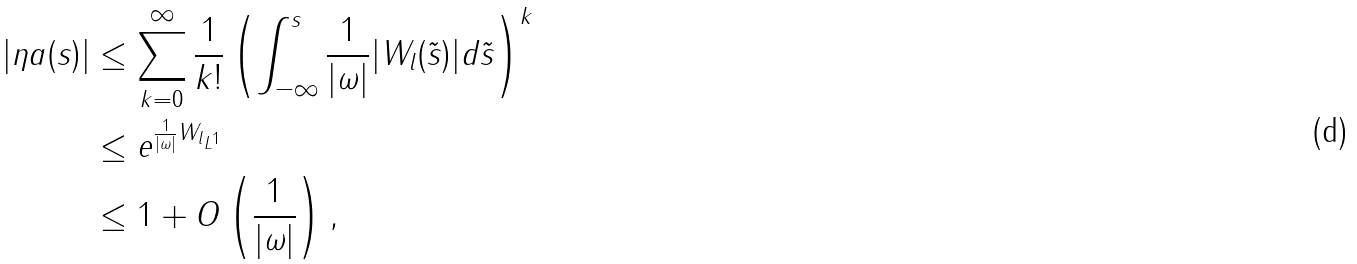<formula> <loc_0><loc_0><loc_500><loc_500>| \eta a ( s ) | & \leq \sum _ { k = 0 } ^ { \infty } \frac { 1 } { k ! } \left ( \int _ { - \infty } ^ { s } \frac { 1 } { | \omega | } | W _ { l } ( \tilde { s } ) | d \tilde { s } \right ) ^ { k } \\ & \leq e ^ { \frac { 1 } { | \omega | } \| W _ { l } \| _ { L ^ { 1 } } } \\ & \leq 1 + O \left ( \frac { 1 } { | \omega | } \right ) ,</formula> 